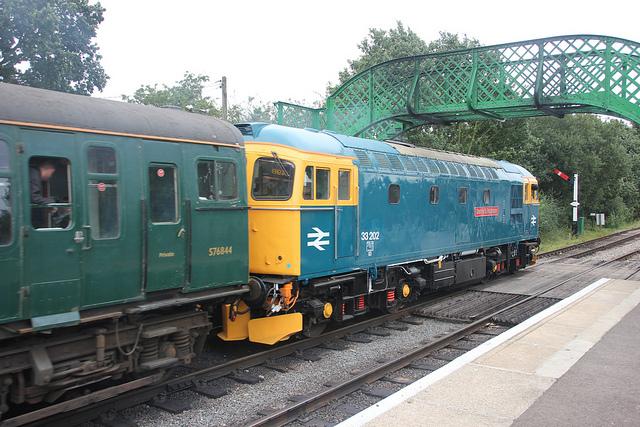Do the two train cars match?
Short answer required. No. Is there a logo visible?
Keep it brief. Yes. How many white circles are on the yellow part of the train?
Quick response, please. 0. Is the train under the bridge?
Write a very short answer. Yes. 